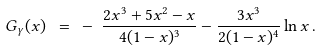<formula> <loc_0><loc_0><loc_500><loc_500>G _ { \gamma } ( x ) \ = \ - \ \frac { 2 x ^ { 3 } + 5 x ^ { 2 } - x } { 4 ( 1 - x ) ^ { 3 } } - \frac { 3 x ^ { 3 } } { 2 ( 1 - x ) ^ { 4 } } \ln x \, .</formula> 